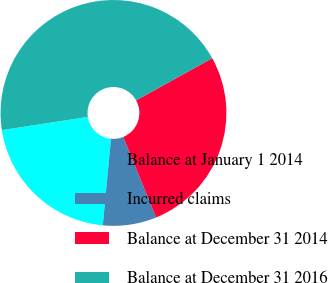<chart> <loc_0><loc_0><loc_500><loc_500><pie_chart><fcel>Balance at January 1 2014<fcel>Incurred claims<fcel>Balance at December 31 2014<fcel>Balance at December 31 2016<nl><fcel>21.06%<fcel>7.67%<fcel>26.89%<fcel>44.38%<nl></chart> 